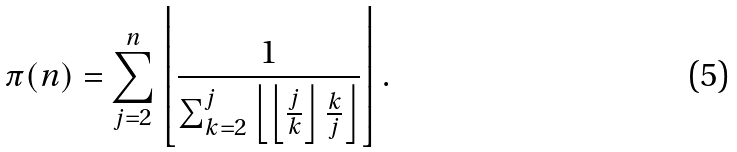<formula> <loc_0><loc_0><loc_500><loc_500>\pi ( n ) = \sum _ { j = 2 } ^ { n } \left \lfloor { \frac { 1 } { \sum _ { k = 2 } ^ { j } \left \lfloor \left \lfloor { \frac { j } { k } } \right \rfloor { \frac { k } { j } } \right \rfloor } } \right \rfloor .</formula> 